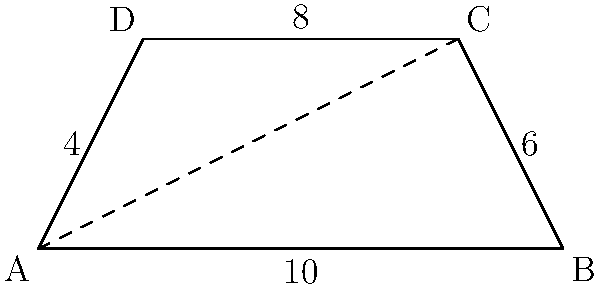In a user story map visualization, the overall project scope is represented by a trapezoid ABCD. If the base lengths are 10 and 8 units, and the height is 4 units, what is the total area of the user story map in square units? To find the area of the trapezoid representing the user story map, we'll follow these steps:

1. Recall the formula for the area of a trapezoid:
   $A = \frac{1}{2}(b_1 + b_2)h$
   where $A$ is the area, $b_1$ and $b_2$ are the lengths of the parallel sides, and $h$ is the height.

2. Identify the given values:
   - Base 1 ($b_1$): 10 units
   - Base 2 ($b_2$): 8 units
   - Height ($h$): 4 units

3. Substitute these values into the formula:
   $A = \frac{1}{2}(10 + 8) \times 4$

4. Simplify:
   $A = \frac{1}{2}(18) \times 4$
   $A = 9 \times 4$
   $A = 36$

Therefore, the total area of the user story map is 36 square units.
Answer: 36 square units 